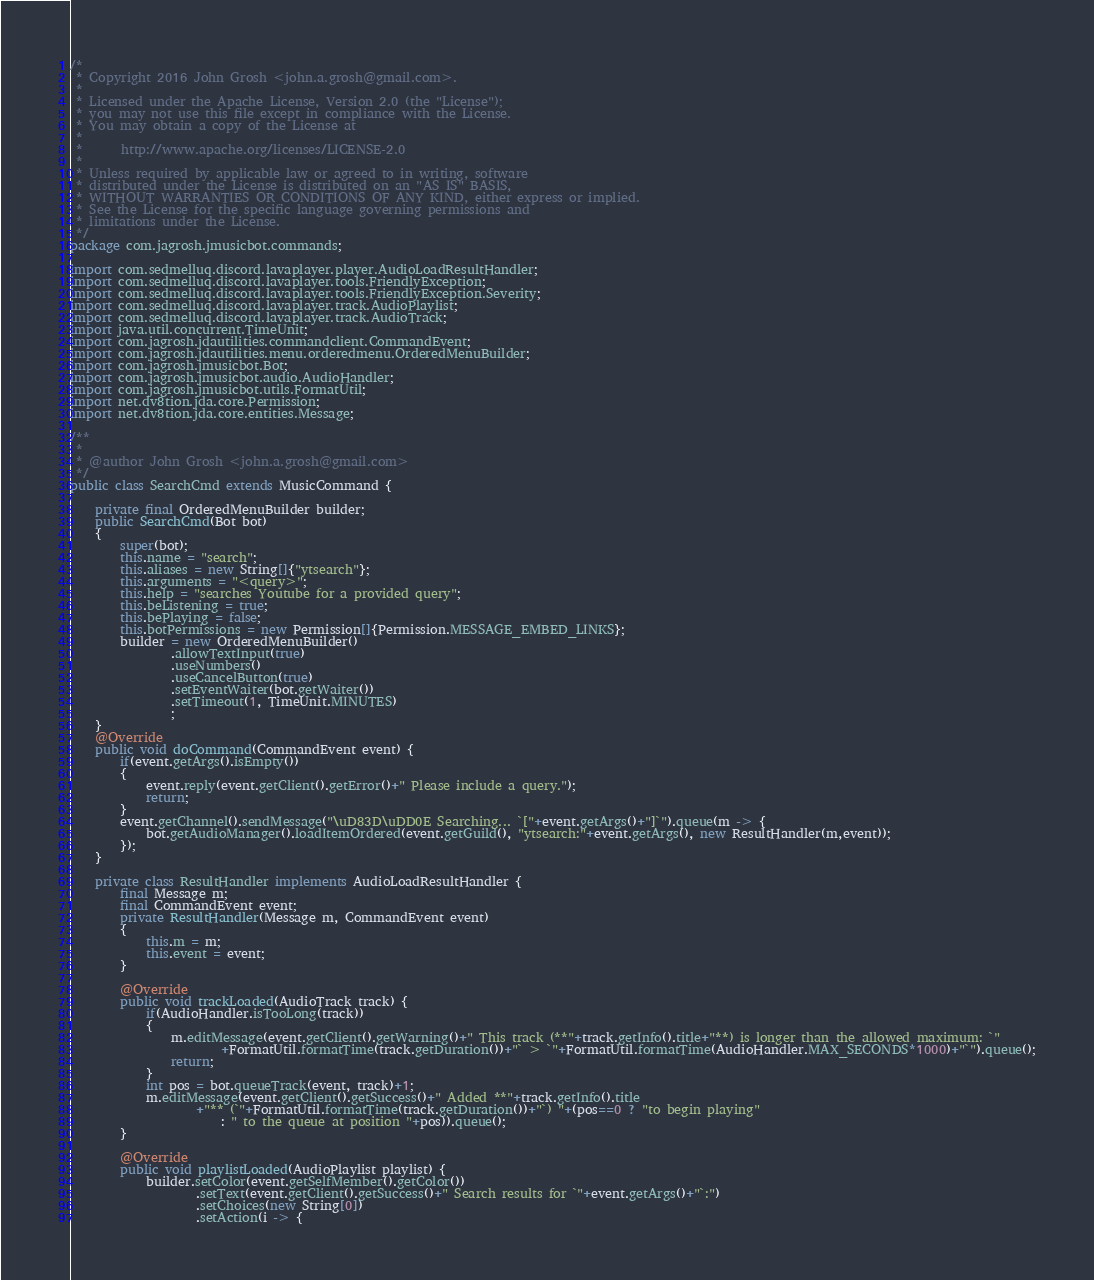Convert code to text. <code><loc_0><loc_0><loc_500><loc_500><_Java_>/*
 * Copyright 2016 John Grosh <john.a.grosh@gmail.com>.
 *
 * Licensed under the Apache License, Version 2.0 (the "License");
 * you may not use this file except in compliance with the License.
 * You may obtain a copy of the License at
 *
 *      http://www.apache.org/licenses/LICENSE-2.0
 *
 * Unless required by applicable law or agreed to in writing, software
 * distributed under the License is distributed on an "AS IS" BASIS,
 * WITHOUT WARRANTIES OR CONDITIONS OF ANY KIND, either express or implied.
 * See the License for the specific language governing permissions and
 * limitations under the License.
 */
package com.jagrosh.jmusicbot.commands;

import com.sedmelluq.discord.lavaplayer.player.AudioLoadResultHandler;
import com.sedmelluq.discord.lavaplayer.tools.FriendlyException;
import com.sedmelluq.discord.lavaplayer.tools.FriendlyException.Severity;
import com.sedmelluq.discord.lavaplayer.track.AudioPlaylist;
import com.sedmelluq.discord.lavaplayer.track.AudioTrack;
import java.util.concurrent.TimeUnit;
import com.jagrosh.jdautilities.commandclient.CommandEvent;
import com.jagrosh.jdautilities.menu.orderedmenu.OrderedMenuBuilder;
import com.jagrosh.jmusicbot.Bot;
import com.jagrosh.jmusicbot.audio.AudioHandler;
import com.jagrosh.jmusicbot.utils.FormatUtil;
import net.dv8tion.jda.core.Permission;
import net.dv8tion.jda.core.entities.Message;

/**
 *
 * @author John Grosh <john.a.grosh@gmail.com>
 */
public class SearchCmd extends MusicCommand {

    private final OrderedMenuBuilder builder;
    public SearchCmd(Bot bot)
    {
        super(bot);
        this.name = "search";
        this.aliases = new String[]{"ytsearch"};
        this.arguments = "<query>";
        this.help = "searches Youtube for a provided query";
        this.beListening = true;
        this.bePlaying = false;
        this.botPermissions = new Permission[]{Permission.MESSAGE_EMBED_LINKS};
        builder = new OrderedMenuBuilder()
                .allowTextInput(true)
                .useNumbers()
                .useCancelButton(true)
                .setEventWaiter(bot.getWaiter())
                .setTimeout(1, TimeUnit.MINUTES)
                ;
    }
    @Override
    public void doCommand(CommandEvent event) {
        if(event.getArgs().isEmpty())
        {
            event.reply(event.getClient().getError()+" Please include a query.");
            return;
        }
        event.getChannel().sendMessage("\uD83D\uDD0E Searching... `["+event.getArgs()+"]`").queue(m -> {
            bot.getAudioManager().loadItemOrdered(event.getGuild(), "ytsearch:"+event.getArgs(), new ResultHandler(m,event));
        });
    }
    
    private class ResultHandler implements AudioLoadResultHandler {
        final Message m;
        final CommandEvent event;
        private ResultHandler(Message m, CommandEvent event)
        {
            this.m = m;
            this.event = event;
        }
        
        @Override
        public void trackLoaded(AudioTrack track) {
            if(AudioHandler.isTooLong(track))
            {
                m.editMessage(event.getClient().getWarning()+" This track (**"+track.getInfo().title+"**) is longer than the allowed maximum: `"
                        +FormatUtil.formatTime(track.getDuration())+"` > `"+FormatUtil.formatTime(AudioHandler.MAX_SECONDS*1000)+"`").queue();
                return;
            }
            int pos = bot.queueTrack(event, track)+1;
            m.editMessage(event.getClient().getSuccess()+" Added **"+track.getInfo().title
                    +"** (`"+FormatUtil.formatTime(track.getDuration())+"`) "+(pos==0 ? "to begin playing" 
                        : " to the queue at position "+pos)).queue();
        }

        @Override
        public void playlistLoaded(AudioPlaylist playlist) {
            builder.setColor(event.getSelfMember().getColor())
                    .setText(event.getClient().getSuccess()+" Search results for `"+event.getArgs()+"`:")
                    .setChoices(new String[0])
                    .setAction(i -> {</code> 